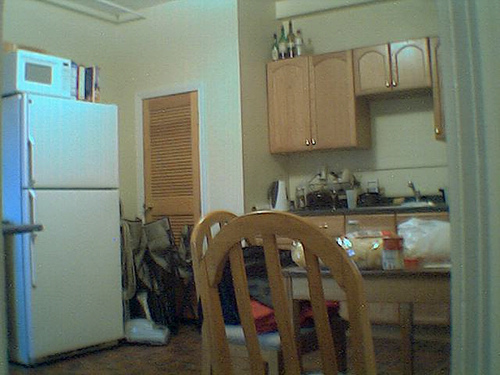<image>How many red chairs are there? There are no red chairs in the image. What type of soda is in the fridge? It's unanswerable what type of soda is in the fridge. It could be coke or root beer. How many red chairs are there? There are no red chairs in the image. What type of soda is in the fridge? It is unknown what type of soda is in the fridge. It is not open. 